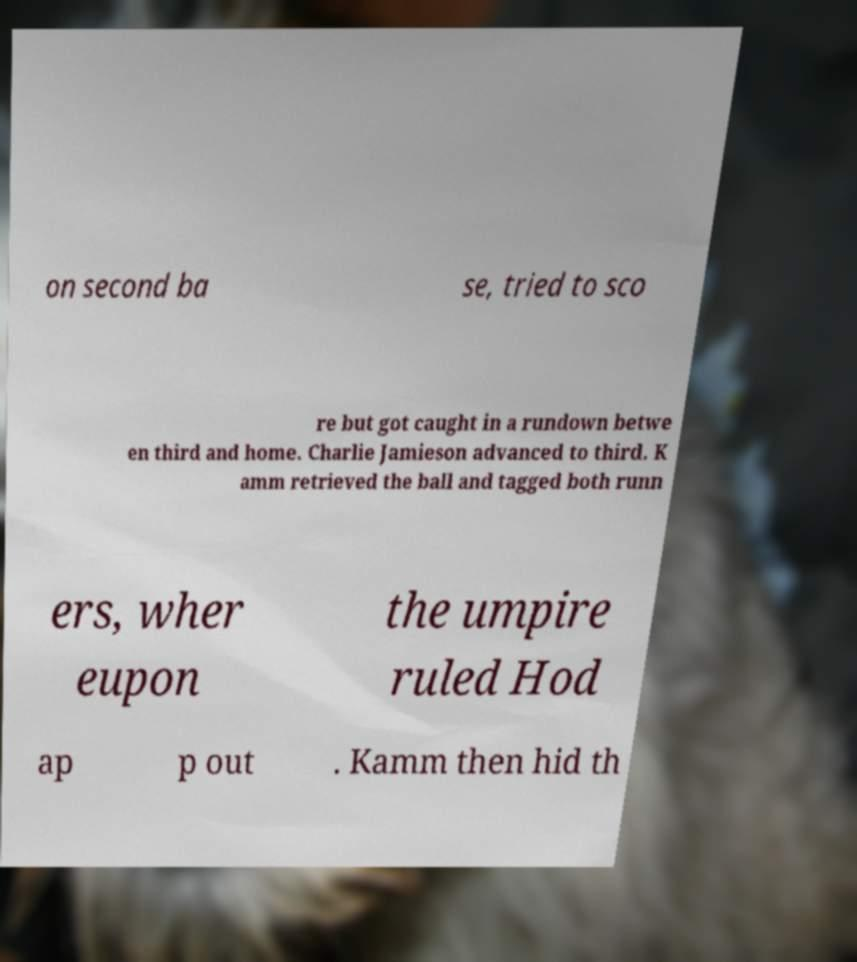For documentation purposes, I need the text within this image transcribed. Could you provide that? on second ba se, tried to sco re but got caught in a rundown betwe en third and home. Charlie Jamieson advanced to third. K amm retrieved the ball and tagged both runn ers, wher eupon the umpire ruled Hod ap p out . Kamm then hid th 